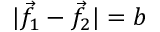<formula> <loc_0><loc_0><loc_500><loc_500>| { \vec { f } } _ { 1 } - { \vec { f } } _ { 2 } | = b</formula> 